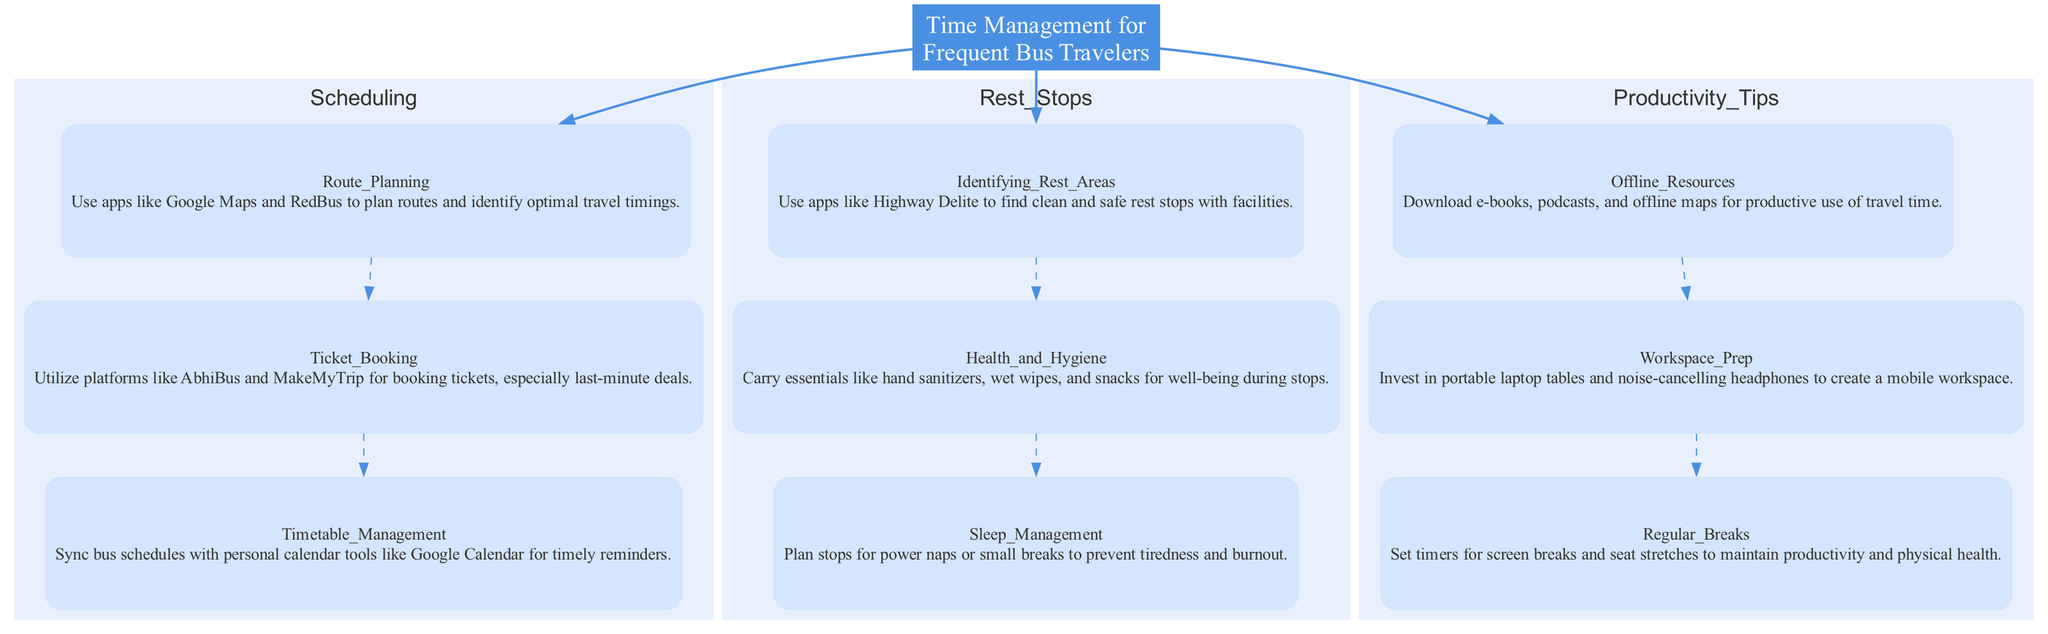What are the three main categories in the diagram? The diagram displays three main categories: Scheduling, Rest Stops, and Productivity Tips. Each category encompasses various elements related to time management for bus travelers.
Answer: Scheduling, Rest Stops, Productivity Tips How many elements are in the Scheduling category? The Scheduling category contains three elements: Route Planning, Ticket Booking, and Timetable Management. This can be counted by reviewing the nodes listed under the Scheduling category.
Answer: 3 What is the relationship between Timetable Management and Ticket Booking? Timetable Management and Ticket Booking are connected indirectly under the Scheduling category, as both elements are part of the same category but are not directly connected by an edge.
Answer: Indirect connection Which application is recommended for Identifying Rest Areas? Highway Delite is the application recommended for identifying clean and safe rest stops with facilities, as mentioned under the Rest Stops category.
Answer: Highway Delite What is the main focus of the Productivity Tips category? The main focus of the Productivity Tips category is to provide strategies for effective use of travel time, which can be reflected in the elements like Offline Resources and Workspace Prep.
Answer: Effective use of travel time How can frequent bus travelers ensure their health and hygiene during rest stops? Travelers can ensure health and hygiene by carrying essentials like hand sanitizers, wet wipes, and snacks, as suggested in the Rest Stops category.
Answer: Carry essentials What element helps with workspace preparation for travel? The element that assists with workspace preparation is Workspace Prep, which suggests investing in portable laptop tables and noise-cancelling headphones.
Answer: Workspace Prep How does the diagram connect different elements within the Scheduling category? The diagram connects different elements within the Scheduling category using dashed edges between them, indicating their relationship and the order of focus in time management.
Answer: Dashed edges What is the importance of Regular Breaks according to the diagram? Regular Breaks are important to maintain productivity and physical health during travel, as they help prevent fatigue and promote well-being, as specified in the Productivity Tips category.
Answer: Maintain productivity and physical health 